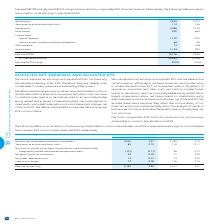According to Bce's financial document, How is adjusted net earnings defined? Based on the financial document, the answer is net earnings attributable to common shareholders before severance, acquisition and other costs, net mark-to-market losses (gains) on derivatives used to economically hedge equity settled share-based compensation plans, net losses (gains) on investments, early debt redemption costs and impairment charges, net of tax and NCI. Also, How is adjusted EPS defined? adjusted net earnings per BCE common share. The document states: "es, net of tax and NCI. We define adjusted EPS as adjusted net earnings per BCE common share...." Also, What is the Net earnings attributable to common shareholders in total for 2019? According to the financial document, 3,040. The relevant text states: "Net earnings attributable to common shareholders 3,040 3.37 2,785 3.10..." Also, can you calculate: What is the change in net earnings attributable to common shareholders per share in 2019? Based on the calculation: 3.37-3.10, the result is 0.27. This is based on the information: "ributable to common shareholders 3,040 3.37 2,785 3.10 arnings attributable to common shareholders 3,040 3.37 2,785 3.10..." The key data points involved are: 3.10, 3.37. Also, can you calculate: What is net earnings attributable to common shareholders as a ratio of the adjusted net earnings in 2018? Based on the calculation: 2,785/3,151, the result is 88.38 (percentage). This is based on the information: "gs attributable to common shareholders 3,040 3.37 2,785 3.10 Adjusted net earnings 3,153 3.50 3,151 3.51..." The key data points involved are: 2,785, 3,151. Also, can you calculate: What is the total early debt redemption costs in 2018 and 2019? Based on the calculation: 13+15, the result is 28. This is based on the information: "Early debt redemption costs 13 0.01 15 0.02 Early debt redemption costs 13 0.01 15 0.02..." The key data points involved are: 13, 15. 